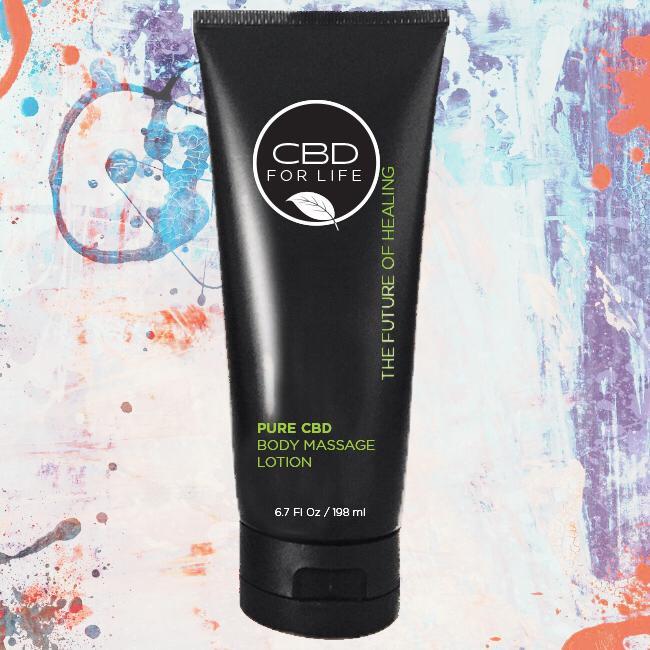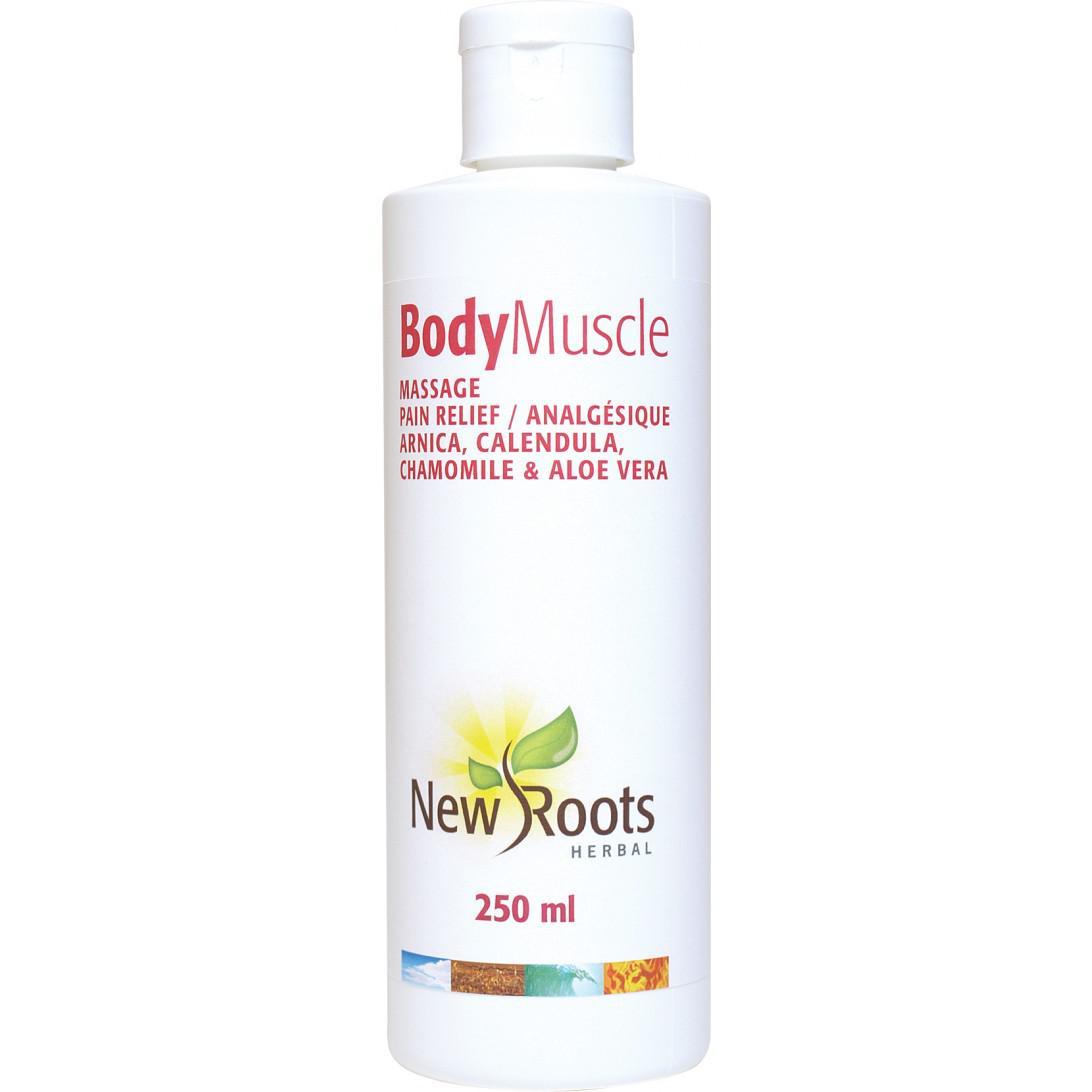The first image is the image on the left, the second image is the image on the right. Assess this claim about the two images: "Each image contains one skincare product on white background.". Correct or not? Answer yes or no. No. The first image is the image on the left, the second image is the image on the right. Analyze the images presented: Is the assertion "At least one bottle of body lotion has a pump top." valid? Answer yes or no. No. 